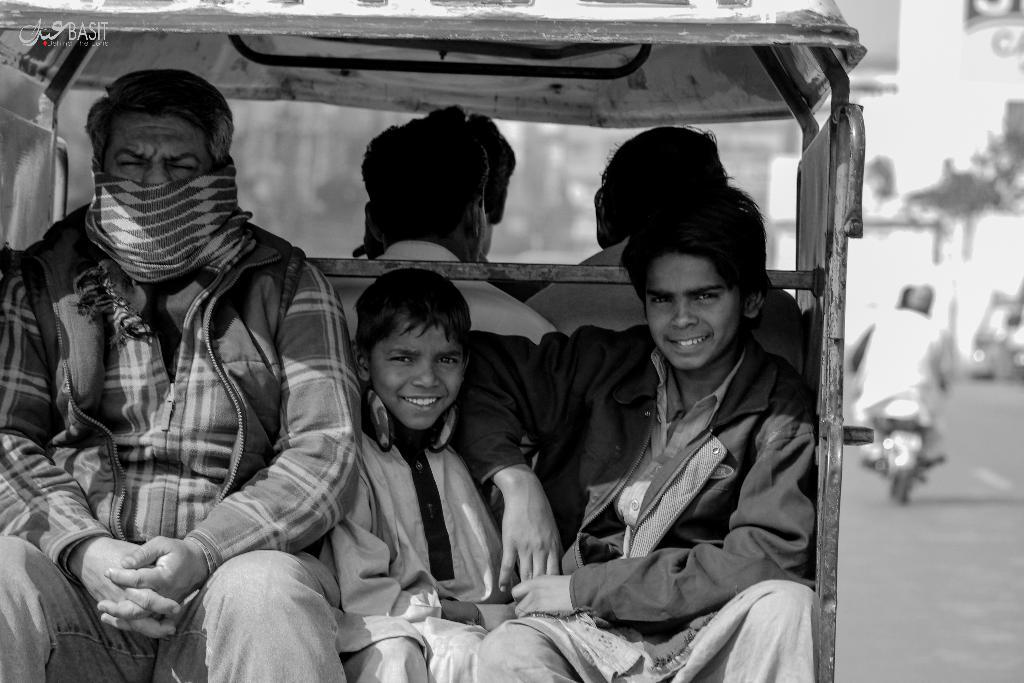What is the main subject in the image? There is a vehicle in the image. Who else is present in the image besides the vehicle? There are persons and kids in the image. What are the persons and kids wearing? They are wearing clothes. Can you describe the activity of one of the persons in the image? There is a person on the right side of the image riding a bike. How many mice can be seen running around the vehicle in the image? There are no mice present in the image. What month is it in the image? The month is not mentioned or depicted in the image. 